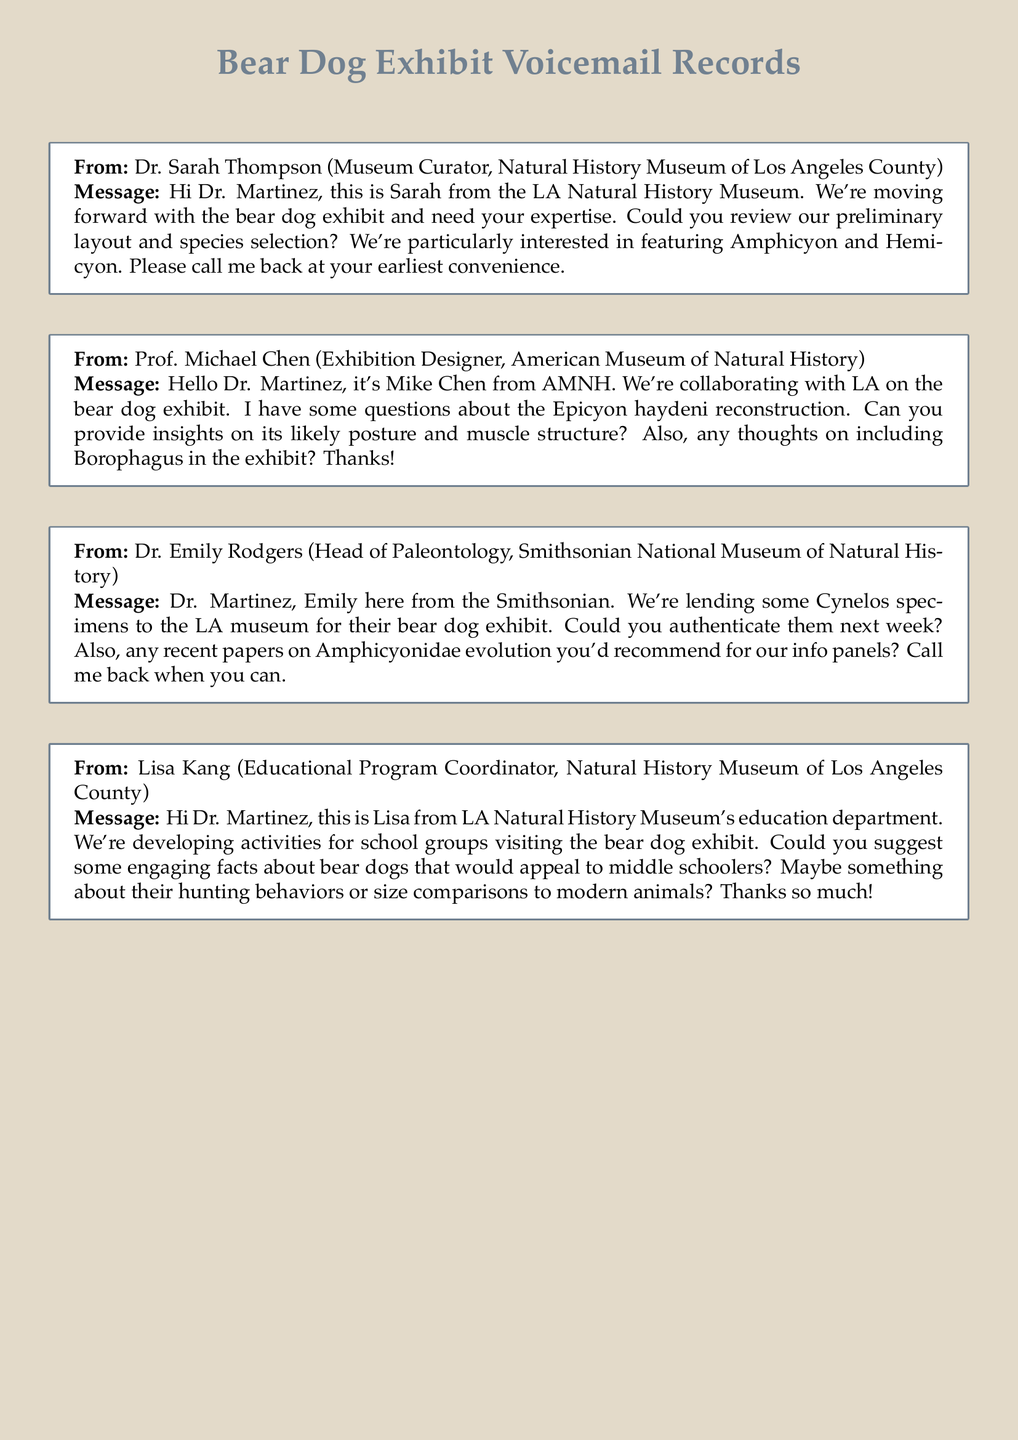What is the name of the museum collaborating on the bear dog exhibit? The message from Prof. Michael Chen mentions that the collaboration is between the LA Natural History Museum and the American Museum of Natural History.
Answer: American Museum of Natural History Who is requesting insights on Epicyon haydeni? Prof. Michael Chen's message specifically asks Dr. Martinez for insights on the Epicyon haydeni reconstruction.
Answer: Prof. Michael Chen What species does Dr. Sarah Thompson want to feature in the exhibit? Dr. Sarah Thompson mentions they are interested in featuring Amphicyon and Hemicyon in her message.
Answer: Amphicyon and Hemicyon What specimens is the Smithsonian lending to the exhibit? Dr. Emily Rodgers mentions that the Smithsonian is lending some Cynelos specimens for the bear dog exhibit.
Answer: Cynelos What type of activities is Lisa Kang developing for the bear dog exhibit? Lisa Kang's message refers to developing activities for school groups visiting the bear dog exhibit.
Answer: Activities for school groups How should bear dogs be compared to modern animals? Lisa Kang's request focuses on engaging facts about bear dogs, specifically size comparisons to modern animals.
Answer: Size comparisons to modern animals When is Dr. Emily Rodgers asking for authentication? Dr. Emily Rodgers asks Dr. Martinez to authenticate the Cynelos specimens next week.
Answer: Next week What is the role of Dr. Sarah Thompson? In the voicemail, she identifies herself as the Museum Curator at the Natural History Museum of Los Angeles County.
Answer: Museum Curator 